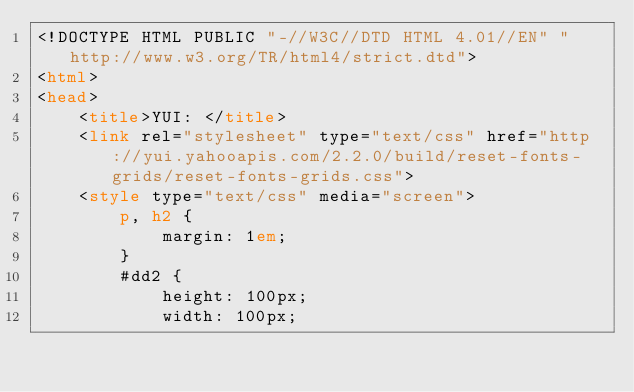Convert code to text. <code><loc_0><loc_0><loc_500><loc_500><_HTML_><!DOCTYPE HTML PUBLIC "-//W3C//DTD HTML 4.01//EN" "http://www.w3.org/TR/html4/strict.dtd">
<html>
<head>
    <title>YUI: </title>
    <link rel="stylesheet" type="text/css" href="http://yui.yahooapis.com/2.2.0/build/reset-fonts-grids/reset-fonts-grids.css"> 
    <style type="text/css" media="screen">
        p, h2 {
            margin: 1em;
        }
        #dd2 {
            height: 100px;
            width: 100px;</code> 